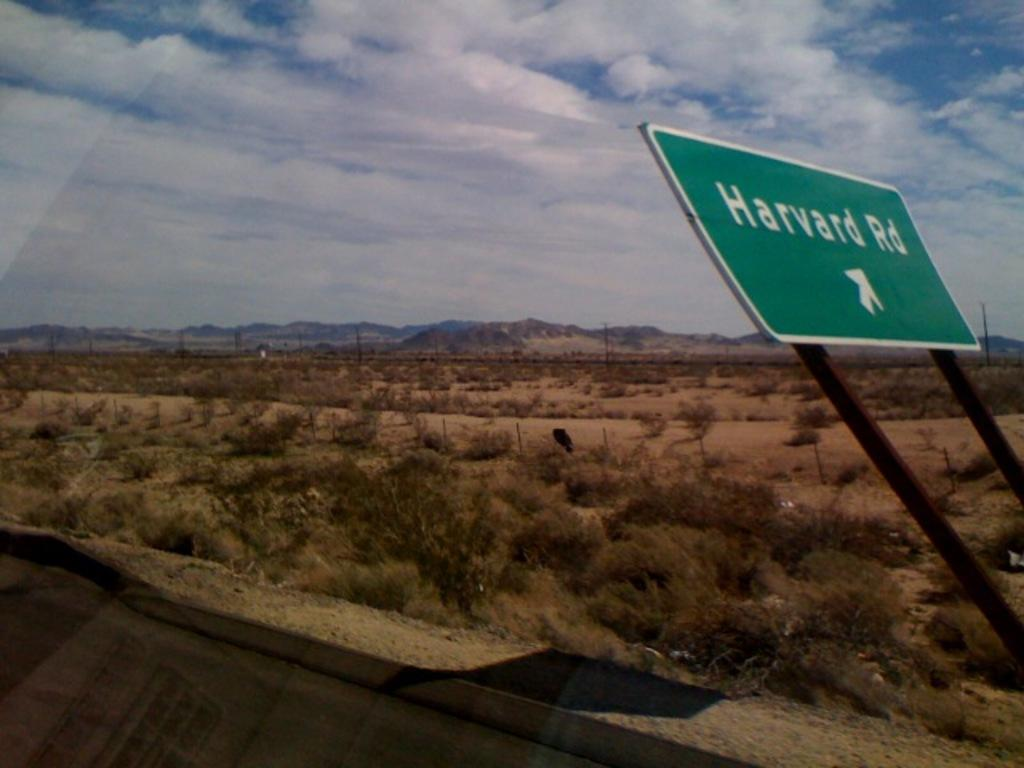<image>
Relay a brief, clear account of the picture shown. A bent over sign for Harvard Road is on the side of the road in the desert. 